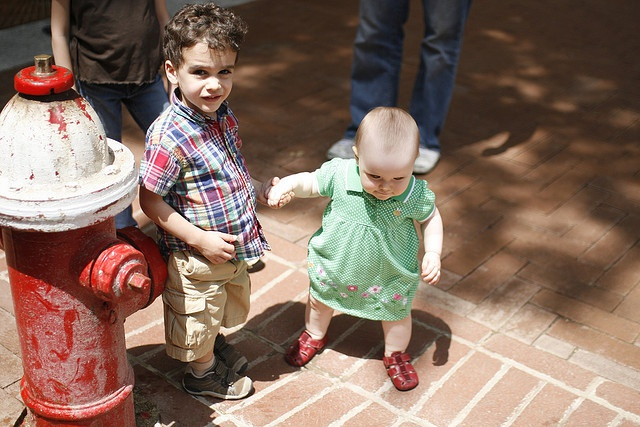Describe the objects in this image and their specific colors. I can see fire hydrant in black, white, maroon, and brown tones, people in black, white, and gray tones, people in black, ivory, green, darkgray, and tan tones, people in black, gray, and maroon tones, and people in black, gray, and darkblue tones in this image. 